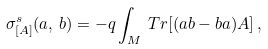Convert formula to latex. <formula><loc_0><loc_0><loc_500><loc_500>\sigma ^ { s } _ { [ { A } ] } ( { a } , \, { b } ) = - q \int _ { M } \, T r [ ( a b - b a ) A ] \, ,</formula> 